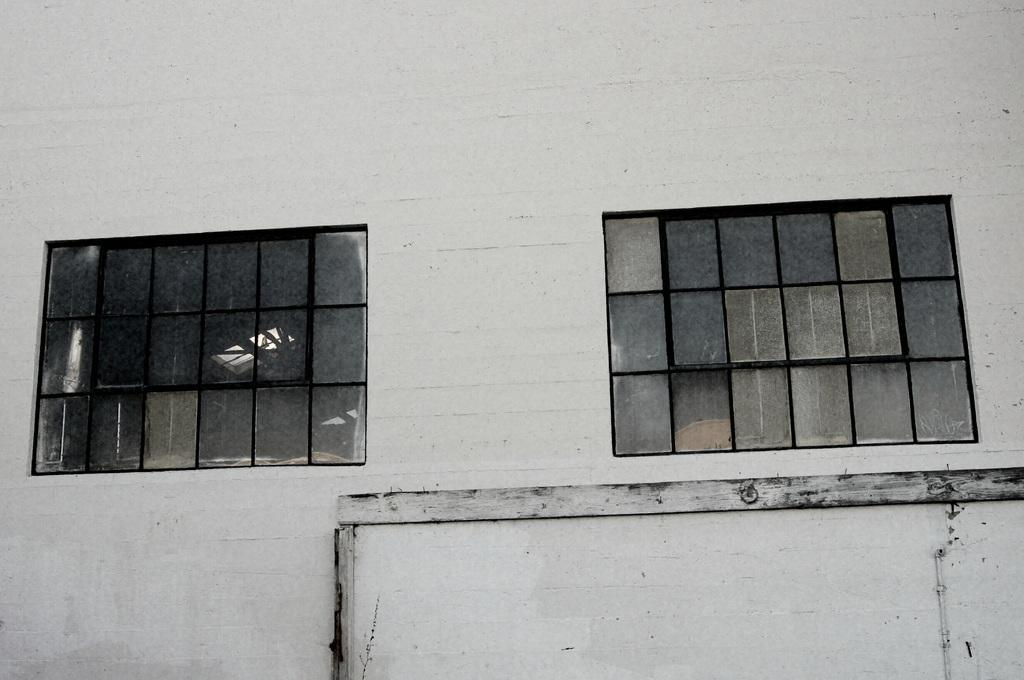What type of structure is present in the image? There is a building in the image. What is the color of the building? The building is white in color. How many glass windows are visible on the building? There are two glass windows on the building. What type of steel is used to construct the pot in the cellar of the building? There is no pot or cellar mentioned in the image, and therefore no steel construction can be observed. 